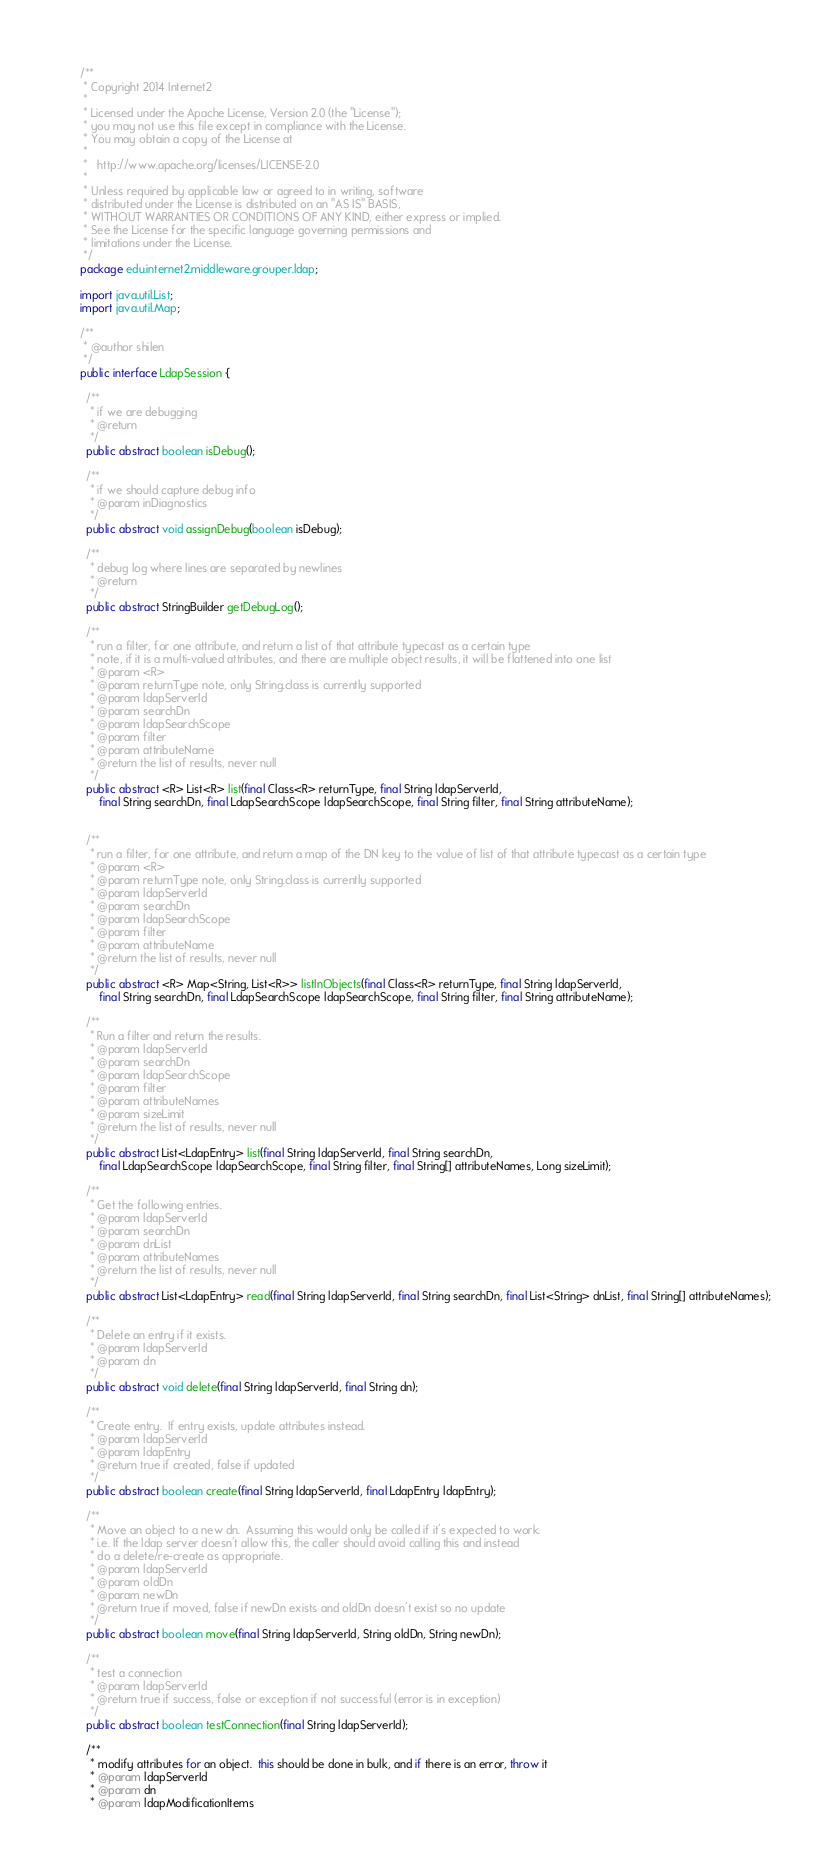<code> <loc_0><loc_0><loc_500><loc_500><_Java_>/**
 * Copyright 2014 Internet2
 *
 * Licensed under the Apache License, Version 2.0 (the "License");
 * you may not use this file except in compliance with the License.
 * You may obtain a copy of the License at
 *
 *   http://www.apache.org/licenses/LICENSE-2.0
 *
 * Unless required by applicable law or agreed to in writing, software
 * distributed under the License is distributed on an "AS IS" BASIS,
 * WITHOUT WARRANTIES OR CONDITIONS OF ANY KIND, either express or implied.
 * See the License for the specific language governing permissions and
 * limitations under the License.
 */
package edu.internet2.middleware.grouper.ldap;

import java.util.List;
import java.util.Map;

/**
 * @author shilen
 */
public interface LdapSession {

  /**
   * if we are debugging
   * @return
   */
  public abstract boolean isDebug();

  /**
   * if we should capture debug info
   * @param inDiagnostics
   */
  public abstract void assignDebug(boolean isDebug);

  /**
   * debug log where lines are separated by newlines
   * @return
   */
  public abstract StringBuilder getDebugLog();
  
  /**
   * run a filter, for one attribute, and return a list of that attribute typecast as a certain type
   * note, if it is a multi-valued attributes, and there are multiple object results, it will be flattened into one list
   * @param <R>
   * @param returnType note, only String.class is currently supported
   * @param ldapServerId
   * @param searchDn
   * @param ldapSearchScope 
   * @param filter
   * @param attributeName
   * @return the list of results, never null
   */
  public abstract <R> List<R> list(final Class<R> returnType, final String ldapServerId, 
      final String searchDn, final LdapSearchScope ldapSearchScope, final String filter, final String attributeName);


  /**
   * run a filter, for one attribute, and return a map of the DN key to the value of list of that attribute typecast as a certain type
   * @param <R>
   * @param returnType note, only String.class is currently supported
   * @param ldapServerId
   * @param searchDn
   * @param ldapSearchScope 
   * @param filter
   * @param attributeName
   * @return the list of results, never null
   */
  public abstract <R> Map<String, List<R>> listInObjects(final Class<R> returnType, final String ldapServerId, 
      final String searchDn, final LdapSearchScope ldapSearchScope, final String filter, final String attributeName);
  
  /**
   * Run a filter and return the results.
   * @param ldapServerId 
   * @param searchDn 
   * @param ldapSearchScope 
   * @param filter 
   * @param attributeNames 
   * @param sizeLimit
   * @return the list of results, never null
   */
  public abstract List<LdapEntry> list(final String ldapServerId, final String searchDn, 
      final LdapSearchScope ldapSearchScope, final String filter, final String[] attributeNames, Long sizeLimit);
  
  /**
   * Get the following entries.
   * @param ldapServerId
   * @param searchDn
   * @param dnList
   * @param attributeNames
   * @return the list of results, never null
   */
  public abstract List<LdapEntry> read(final String ldapServerId, final String searchDn, final List<String> dnList, final String[] attributeNames);
  
  /**
   * Delete an entry if it exists.
   * @param ldapServerId
   * @param dn
   */
  public abstract void delete(final String ldapServerId, final String dn);
  
  /**
   * Create entry.  If entry exists, update attributes instead.
   * @param ldapServerId
   * @param ldapEntry
   * @return true if created, false if updated
   */
  public abstract boolean create(final String ldapServerId, final LdapEntry ldapEntry);
  
  /**
   * Move an object to a new dn.  Assuming this would only be called if it's expected to work.
   * i.e. If the ldap server doesn't allow this, the caller should avoid calling this and instead
   * do a delete/re-create as appropriate.
   * @param ldapServerId
   * @param oldDn
   * @param newDn
   * @return true if moved, false if newDn exists and oldDn doesn't exist so no update
   */
  public abstract boolean move(final String ldapServerId, String oldDn, String newDn);
  
  /**
   * test a connection
   * @param ldapServerId
   * @return true if success, false or exception if not successful (error is in exception)
   */
  public abstract boolean testConnection(final String ldapServerId);
  
  /**
   * modify attributes for an object.  this should be done in bulk, and if there is an error, throw it
   * @param ldapServerId
   * @param dn
   * @param ldapModificationItems</code> 